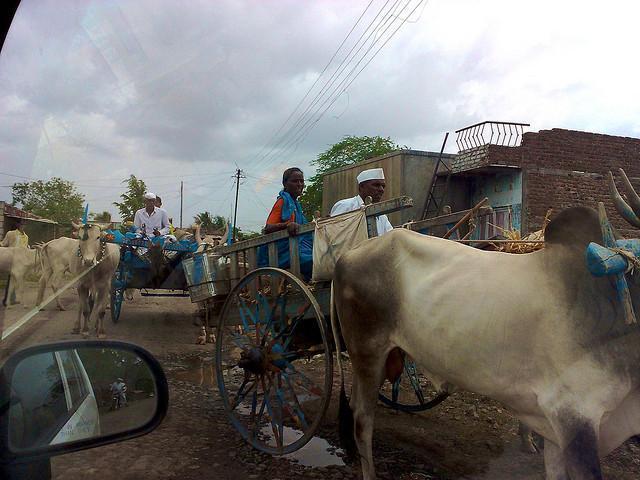How many people are in this picture?
Give a very brief answer. 3. How many wheels are on the cart on the left?
Give a very brief answer. 2. How many cows are there?
Give a very brief answer. 2. 